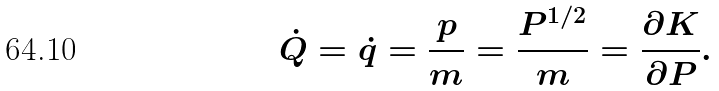<formula> <loc_0><loc_0><loc_500><loc_500>\dot { Q } = \dot { q } = \frac { p } { m } = \frac { P ^ { 1 / 2 } } { m } = \frac { \partial K } { \partial P } .</formula> 